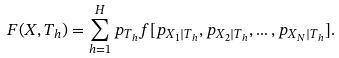Convert formula to latex. <formula><loc_0><loc_0><loc_500><loc_500>F ( X , T _ { h } ) = \sum _ { h = 1 } ^ { H } p _ { T _ { h } } f [ p _ { X _ { 1 } | T _ { h } } , p _ { X _ { 2 } | T _ { h } } , \dots , p _ { X _ { N } | T _ { h } } ] .</formula> 